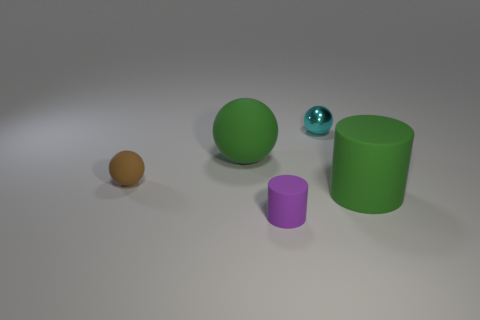Subtract all matte spheres. How many spheres are left? 1 Add 2 tiny purple matte objects. How many objects exist? 7 Subtract all spheres. How many objects are left? 2 Subtract 0 red blocks. How many objects are left? 5 Subtract all brown balls. Subtract all cyan metallic spheres. How many objects are left? 3 Add 5 metallic spheres. How many metallic spheres are left? 6 Add 4 tiny metal spheres. How many tiny metal spheres exist? 5 